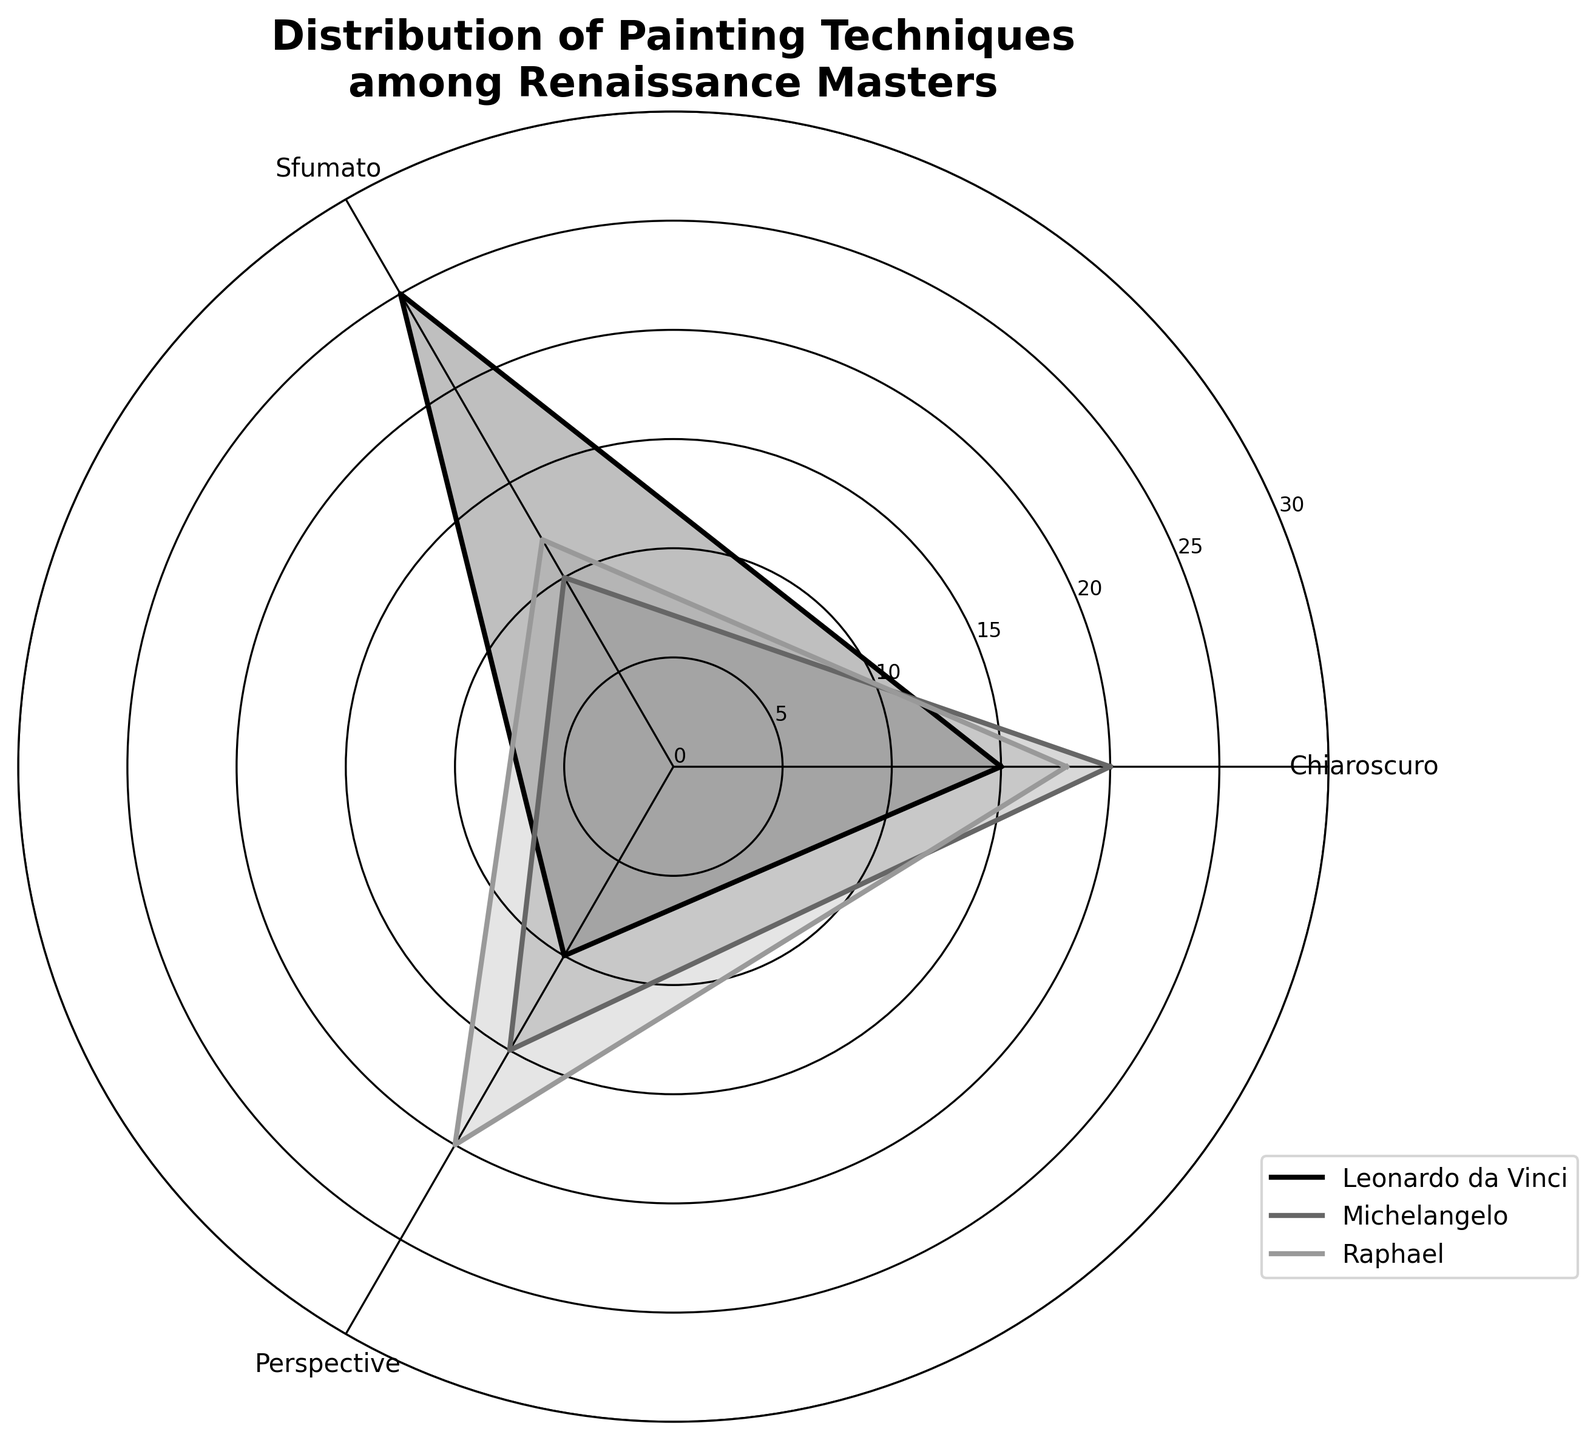What's the title of the chart? The title is prominently displayed at the top of the chart and reads "Distribution of Painting Techniques among Renaissance Masters".
Answer: Distribution of Painting Techniques among Renaissance Masters What are the names of the artists represented in the chart? The names of the artists are visible in the legend box. The artists are Leonardo da Vinci, Michelangelo, and Raphael.
Answer: Leonardo da Vinci, Michelangelo, Raphael Which technique is most frequently used by Leonardo da Vinci? By observing the lengths of the radial lines, it's evident that Leonardo da Vinci has the longest segment for Sfumato.
Answer: Sfumato How many chiaroscuro paintings are there in total for all three artists? Adding the counts for Chiaroscuro: Leonardo da Vinci (15), Michelangelo (20), and Raphael (18). Total = 15 + 20 + 18 = 53.
Answer: 53 What is the difference in the number of perspective paintings between Raphael and Michelangelo? Raphael has 20 Perspective paintings, while Michelangelo has 15. The difference is 20 - 15 = 5.
Answer: 5 Which artist has the smallest number of Sfumato paintings? By looking at Sfumato segments, Michelangelo has the smallest number, with only 10 Sfumato paintings.
Answer: Michelangelo What is the average number of paintings per technique for Michelangelo? Michelangelo has 20 Chiaroscuro, 10 Sfumato, and 15 Perspective paintings. The average is (20 + 10 + 15) / 3 = 15.
Answer: 15 Which technique is least used by Leonardo da Vinci? Leonardo da Vinci has the smallest count of Perspective paintings (10).
Answer: Perspective Compare the total number of paintings using Chiaroscuro between any two artists. For example, comparing Leonardo da Vinci (15) and Raphael (18): Raphael has 3 more Chiaroscuro paintings than Leonardo da Vinci.
Answer: Raphael has 3 more Among the three artists, who has the most balanced distribution across techniques? By comparing the lengths of the segments for each artist, Michelangelo has relatively close counts (20 Chiaroscuro, 10 Sfumato, 15 Perspective), indicating a more balanced distribution.
Answer: Michelangelo 